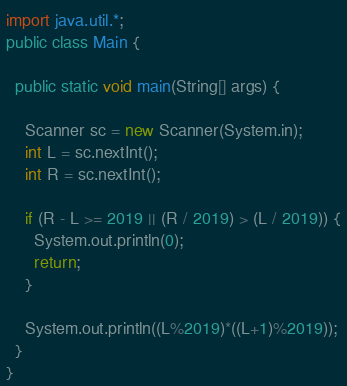Convert code to text. <code><loc_0><loc_0><loc_500><loc_500><_Java_>import java.util.*;
public class Main {
  
  public static void main(String[] args) {

    Scanner sc = new Scanner(System.in);
    int L = sc.nextInt();
    int R = sc.nextInt();
    
    if (R - L >= 2019 || (R / 2019) > (L / 2019)) {
      System.out.println(0);
      return;
    }
    
    System.out.println((L%2019)*((L+1)%2019));
  }  
}
</code> 